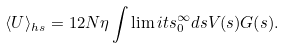<formula> <loc_0><loc_0><loc_500><loc_500>\langle U \rangle _ { h s } = 1 2 N \eta \int \lim i t s _ { 0 } ^ { \infty } d s V ( s ) G ( s ) .</formula> 